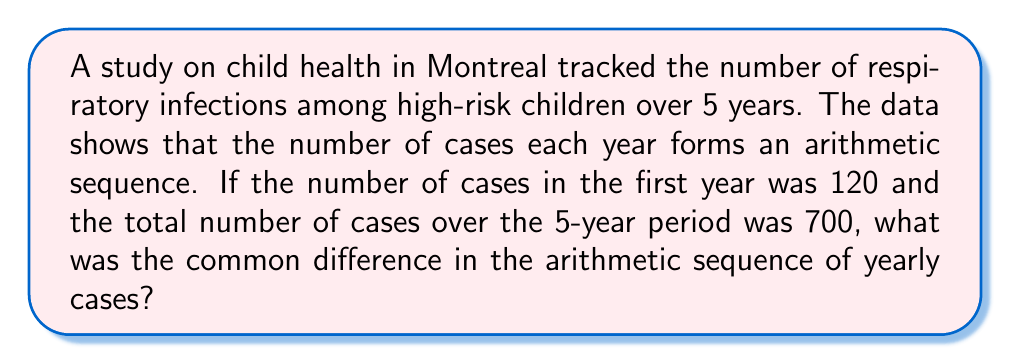Give your solution to this math problem. Let's approach this step-by-step using arithmetic sequence properties:

1) Let $a$ be the first term (120) and $d$ be the common difference.

2) The arithmetic sequence for the 5 years would be:
   $a, a+d, a+2d, a+3d, a+4d$

3) The sum of an arithmetic sequence is given by:
   $S_n = \frac{n}{2}(a_1 + a_n)$, where $n$ is the number of terms

4) We know that $S_5 = 700$, $a_1 = 120$, and $a_5 = 120 + 4d$

5) Substituting into the sum formula:
   $700 = \frac{5}{2}(120 + (120 + 4d))$

6) Simplifying:
   $700 = \frac{5}{2}(240 + 4d)$
   $700 = 600 + 10d$

7) Solving for $d$:
   $100 = 10d$
   $d = 10$

Therefore, the common difference in the arithmetic sequence is 10.
Answer: $10$ 